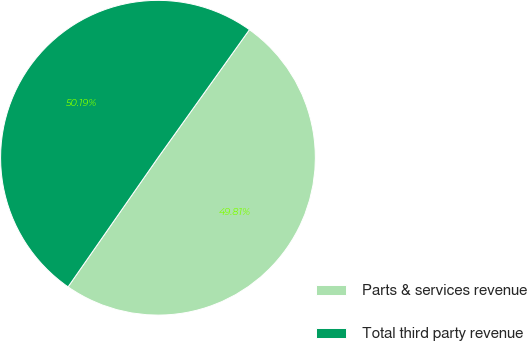Convert chart. <chart><loc_0><loc_0><loc_500><loc_500><pie_chart><fcel>Parts & services revenue<fcel>Total third party revenue<nl><fcel>49.81%<fcel>50.19%<nl></chart> 